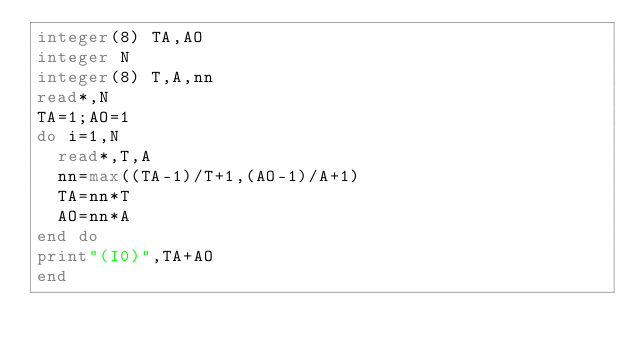<code> <loc_0><loc_0><loc_500><loc_500><_FORTRAN_>integer(8) TA,AO
integer N
integer(8) T,A,nn
read*,N
TA=1;AO=1
do i=1,N
  read*,T,A
  nn=max((TA-1)/T+1,(AO-1)/A+1)
  TA=nn*T
  AO=nn*A
end do
print"(I0)",TA+AO
end</code> 